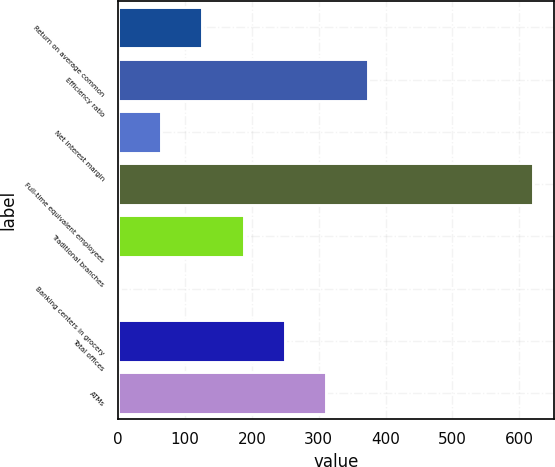Convert chart to OTSL. <chart><loc_0><loc_0><loc_500><loc_500><bar_chart><fcel>Return on average common<fcel>Efficiency ratio<fcel>Net interest margin<fcel>Full-time equivalent employees<fcel>Traditional branches<fcel>Banking centers in grocery<fcel>Total offices<fcel>ATMs<nl><fcel>125.8<fcel>373.4<fcel>63.9<fcel>621<fcel>187.7<fcel>2<fcel>249.6<fcel>311.5<nl></chart> 